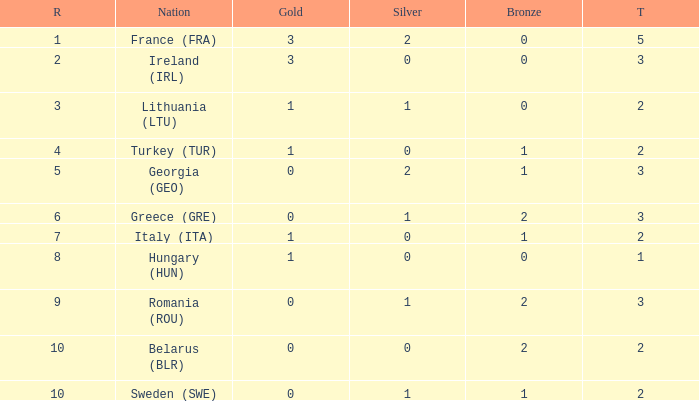What are the most bronze medals in a rank more than 1 with a total larger than 3? None. 